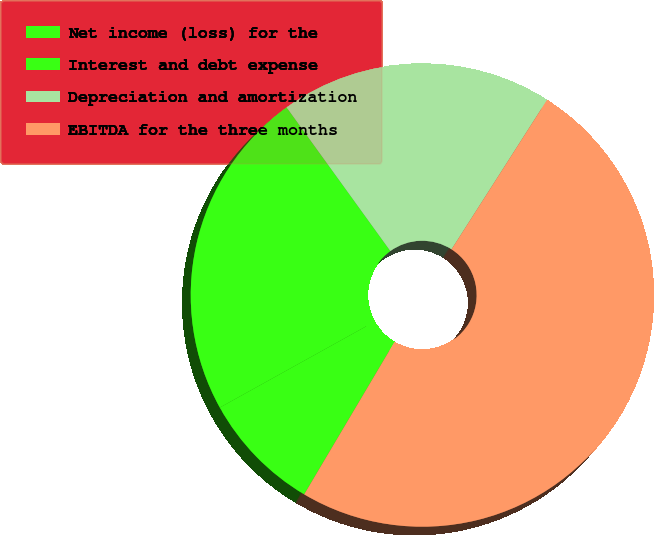<chart> <loc_0><loc_0><loc_500><loc_500><pie_chart><fcel>Net income (loss) for the<fcel>Interest and debt expense<fcel>Depreciation and amortization<fcel>EBITDA for the three months<nl><fcel>8.42%<fcel>23.11%<fcel>19.01%<fcel>49.46%<nl></chart> 